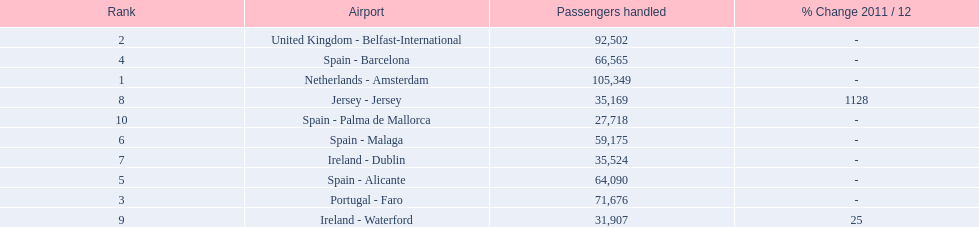What is the name of the only airport in portugal that is among the 10 busiest routes to and from london southend airport in 2012? Portugal - Faro. 